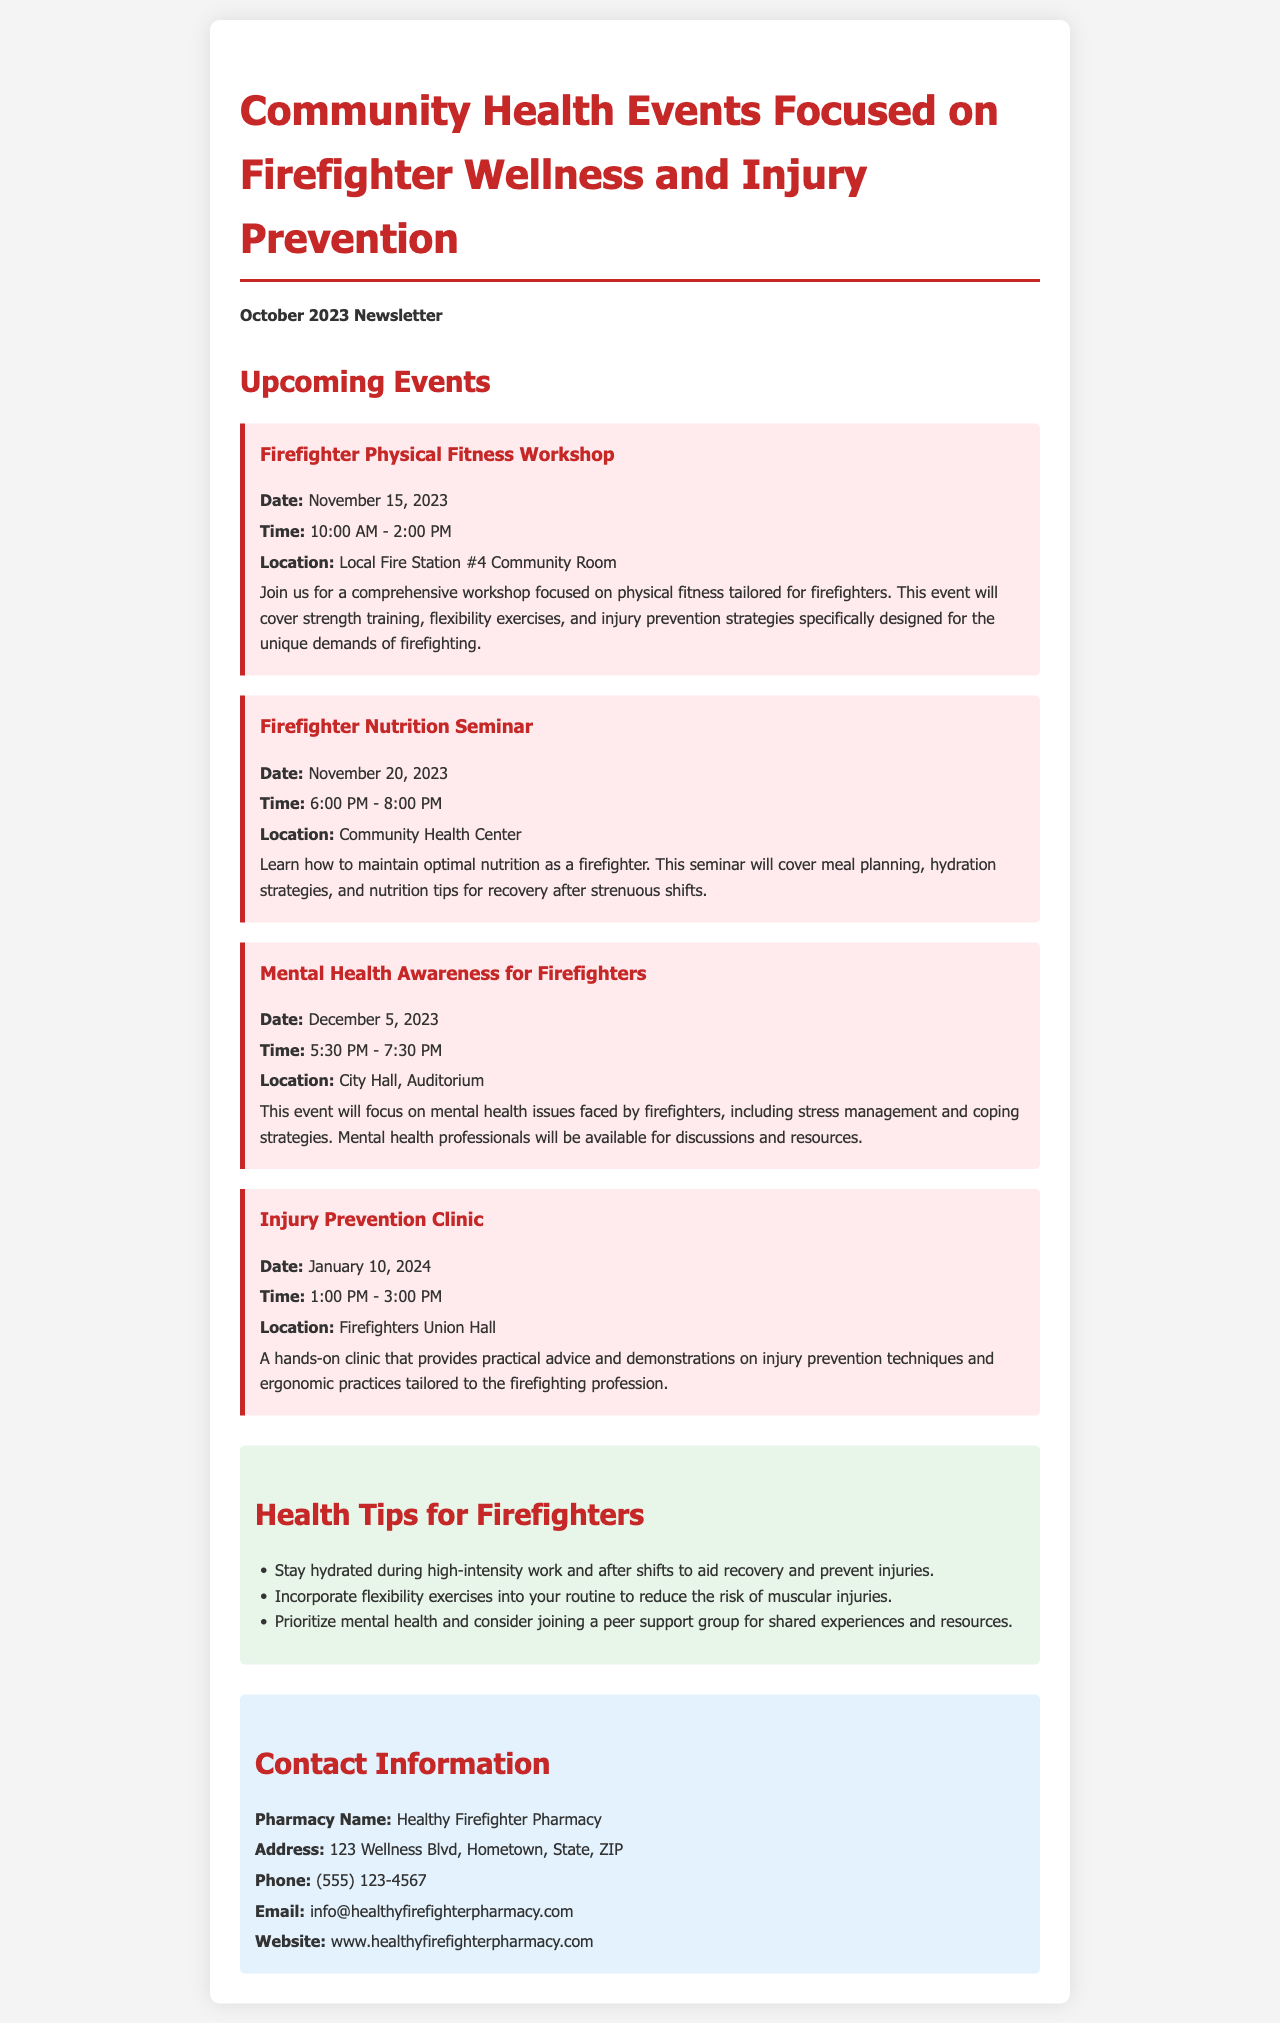What is the date of the Firefighter Physical Fitness Workshop? The date of the Firefighter Physical Fitness Workshop is specified in the document as November 15, 2023.
Answer: November 15, 2023 What time does the Firefighter Nutrition Seminar start? The start time of the Firefighter Nutrition Seminar is mentioned as 6:00 PM.
Answer: 6:00 PM Where is the Mental Health Awareness for Firefighters event held? The location for the Mental Health Awareness for Firefighters event is stated to be City Hall, Auditorium.
Answer: City Hall, Auditorium What is one topic covered in the Injury Prevention Clinic? The document lists injury prevention techniques and ergonomic practices as topics covered in the Injury Prevention Clinic.
Answer: Injury prevention techniques How many health tips are provided for firefighters? The document contains a list of health tips, which totals to three tips provided for firefighters.
Answer: Three tips What is the name of the pharmacy mentioned in the contact information? The name of the pharmacy is explicitly stated in the document as Healthy Firefighter Pharmacy.
Answer: Healthy Firefighter Pharmacy What type of workshop is being conducted on November 15, 2023? The workshop that is occurring on that date is focused on physical fitness tailored for firefighters.
Answer: Physical fitness workshop What is the purpose of the Mental Health Awareness for Firefighters event? The document explains that the event focuses on mental health issues faced by firefighters, including stress management and coping strategies.
Answer: Mental health issues and coping strategies When is the Injury Prevention Clinic scheduled? The date for the Injury Prevention Clinic is given as January 10, 2024.
Answer: January 10, 2024 